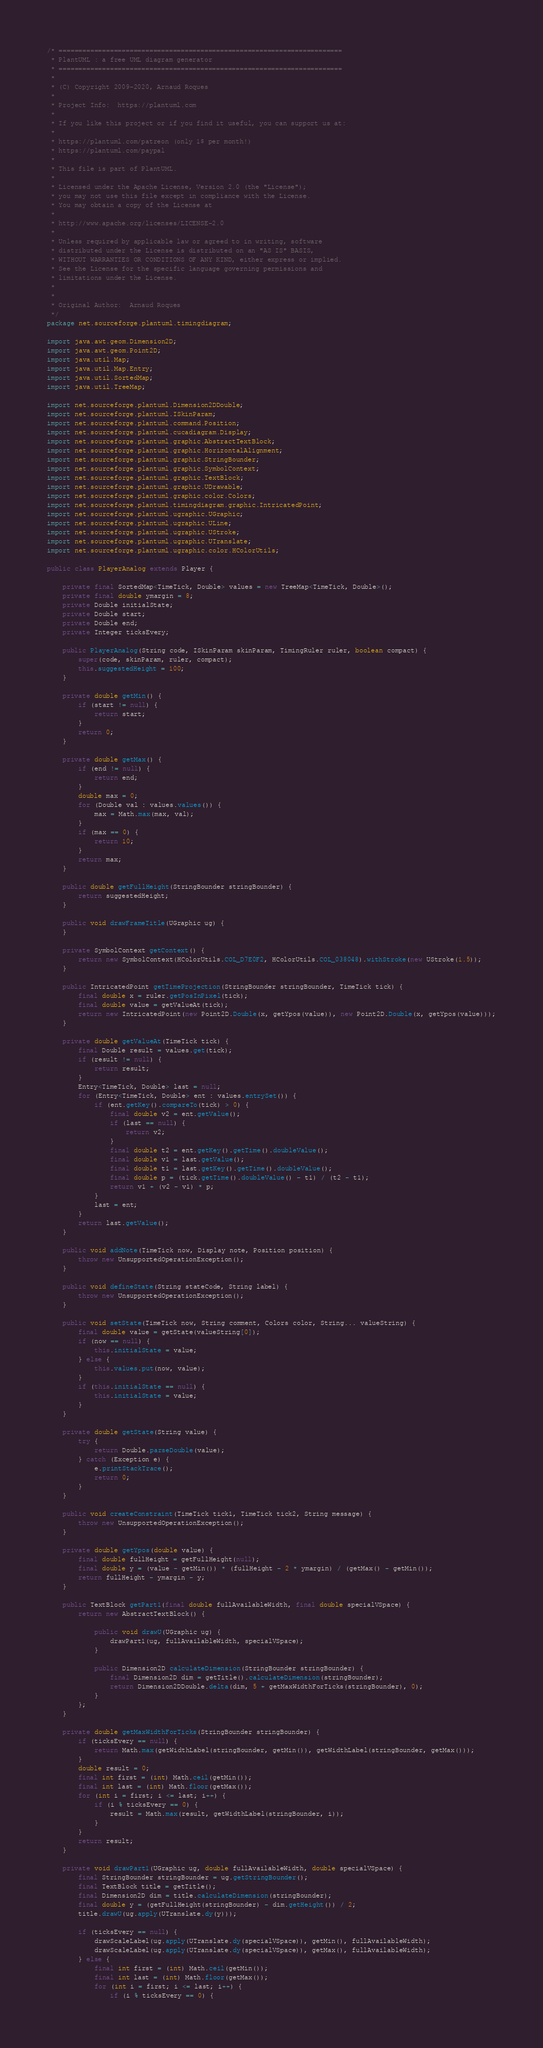Convert code to text. <code><loc_0><loc_0><loc_500><loc_500><_Java_>/* ========================================================================
 * PlantUML : a free UML diagram generator
 * ========================================================================
 *
 * (C) Copyright 2009-2020, Arnaud Roques
 *
 * Project Info:  https://plantuml.com
 * 
 * If you like this project or if you find it useful, you can support us at:
 * 
 * https://plantuml.com/patreon (only 1$ per month!)
 * https://plantuml.com/paypal
 * 
 * This file is part of PlantUML.
 *
 * Licensed under the Apache License, Version 2.0 (the "License");
 * you may not use this file except in compliance with the License.
 * You may obtain a copy of the License at
 * 
 * http://www.apache.org/licenses/LICENSE-2.0
 * 
 * Unless required by applicable law or agreed to in writing, software
 * distributed under the License is distributed on an "AS IS" BASIS,
 * WITHOUT WARRANTIES OR CONDITIONS OF ANY KIND, either express or implied.
 * See the License for the specific language governing permissions and
 * limitations under the License.
 *
 *
 * Original Author:  Arnaud Roques
 */
package net.sourceforge.plantuml.timingdiagram;

import java.awt.geom.Dimension2D;
import java.awt.geom.Point2D;
import java.util.Map;
import java.util.Map.Entry;
import java.util.SortedMap;
import java.util.TreeMap;

import net.sourceforge.plantuml.Dimension2DDouble;
import net.sourceforge.plantuml.ISkinParam;
import net.sourceforge.plantuml.command.Position;
import net.sourceforge.plantuml.cucadiagram.Display;
import net.sourceforge.plantuml.graphic.AbstractTextBlock;
import net.sourceforge.plantuml.graphic.HorizontalAlignment;
import net.sourceforge.plantuml.graphic.StringBounder;
import net.sourceforge.plantuml.graphic.SymbolContext;
import net.sourceforge.plantuml.graphic.TextBlock;
import net.sourceforge.plantuml.graphic.UDrawable;
import net.sourceforge.plantuml.graphic.color.Colors;
import net.sourceforge.plantuml.timingdiagram.graphic.IntricatedPoint;
import net.sourceforge.plantuml.ugraphic.UGraphic;
import net.sourceforge.plantuml.ugraphic.ULine;
import net.sourceforge.plantuml.ugraphic.UStroke;
import net.sourceforge.plantuml.ugraphic.UTranslate;
import net.sourceforge.plantuml.ugraphic.color.HColorUtils;

public class PlayerAnalog extends Player {

	private final SortedMap<TimeTick, Double> values = new TreeMap<TimeTick, Double>();
	private final double ymargin = 8;
	private Double initialState;
	private Double start;
	private Double end;
	private Integer ticksEvery;

	public PlayerAnalog(String code, ISkinParam skinParam, TimingRuler ruler, boolean compact) {
		super(code, skinParam, ruler, compact);
		this.suggestedHeight = 100;
	}

	private double getMin() {
		if (start != null) {
			return start;
		}
		return 0;
	}

	private double getMax() {
		if (end != null) {
			return end;
		}
		double max = 0;
		for (Double val : values.values()) {
			max = Math.max(max, val);
		}
		if (max == 0) {
			return 10;
		}
		return max;
	}

	public double getFullHeight(StringBounder stringBounder) {
		return suggestedHeight;
	}

	public void drawFrameTitle(UGraphic ug) {
	}

	private SymbolContext getContext() {
		return new SymbolContext(HColorUtils.COL_D7E0F2, HColorUtils.COL_038048).withStroke(new UStroke(1.5));
	}

	public IntricatedPoint getTimeProjection(StringBounder stringBounder, TimeTick tick) {
		final double x = ruler.getPosInPixel(tick);
		final double value = getValueAt(tick);
		return new IntricatedPoint(new Point2D.Double(x, getYpos(value)), new Point2D.Double(x, getYpos(value)));
	}

	private double getValueAt(TimeTick tick) {
		final Double result = values.get(tick);
		if (result != null) {
			return result;
		}
		Entry<TimeTick, Double> last = null;
		for (Entry<TimeTick, Double> ent : values.entrySet()) {
			if (ent.getKey().compareTo(tick) > 0) {
				final double v2 = ent.getValue();
				if (last == null) {
					return v2;
				}
				final double t2 = ent.getKey().getTime().doubleValue();
				final double v1 = last.getValue();
				final double t1 = last.getKey().getTime().doubleValue();
				final double p = (tick.getTime().doubleValue() - t1) / (t2 - t1);
				return v1 + (v2 - v1) * p;
			}
			last = ent;
		}
		return last.getValue();
	}

	public void addNote(TimeTick now, Display note, Position position) {
		throw new UnsupportedOperationException();
	}

	public void defineState(String stateCode, String label) {
		throw new UnsupportedOperationException();
	}

	public void setState(TimeTick now, String comment, Colors color, String... valueString) {
		final double value = getState(valueString[0]);
		if (now == null) {
			this.initialState = value;
		} else {
			this.values.put(now, value);
		}
		if (this.initialState == null) {
			this.initialState = value;
		}
	}

	private double getState(String value) {
		try {
			return Double.parseDouble(value);
		} catch (Exception e) {
			e.printStackTrace();
			return 0;
		}
	}

	public void createConstraint(TimeTick tick1, TimeTick tick2, String message) {
		throw new UnsupportedOperationException();
	}

	private double getYpos(double value) {
		final double fullHeight = getFullHeight(null);
		final double y = (value - getMin()) * (fullHeight - 2 * ymargin) / (getMax() - getMin());
		return fullHeight - ymargin - y;
	}

	public TextBlock getPart1(final double fullAvailableWidth, final double specialVSpace) {
		return new AbstractTextBlock() {

			public void drawU(UGraphic ug) {
				drawPart1(ug, fullAvailableWidth, specialVSpace);
			}

			public Dimension2D calculateDimension(StringBounder stringBounder) {
				final Dimension2D dim = getTitle().calculateDimension(stringBounder);
				return Dimension2DDouble.delta(dim, 5 + getMaxWidthForTicks(stringBounder), 0);
			}
		};
	}

	private double getMaxWidthForTicks(StringBounder stringBounder) {
		if (ticksEvery == null) {
			return Math.max(getWidthLabel(stringBounder, getMin()), getWidthLabel(stringBounder, getMax()));
		}
		double result = 0;
		final int first = (int) Math.ceil(getMin());
		final int last = (int) Math.floor(getMax());
		for (int i = first; i <= last; i++) {
			if (i % ticksEvery == 0) {
				result = Math.max(result, getWidthLabel(stringBounder, i));
			}
		}
		return result;
	}

	private void drawPart1(UGraphic ug, double fullAvailableWidth, double specialVSpace) {
		final StringBounder stringBounder = ug.getStringBounder();
		final TextBlock title = getTitle();
		final Dimension2D dim = title.calculateDimension(stringBounder);
		final double y = (getFullHeight(stringBounder) - dim.getHeight()) / 2;
		title.drawU(ug.apply(UTranslate.dy(y)));

		if (ticksEvery == null) {
			drawScaleLabel(ug.apply(UTranslate.dy(specialVSpace)), getMin(), fullAvailableWidth);
			drawScaleLabel(ug.apply(UTranslate.dy(specialVSpace)), getMax(), fullAvailableWidth);
		} else {
			final int first = (int) Math.ceil(getMin());
			final int last = (int) Math.floor(getMax());
			for (int i = first; i <= last; i++) {
				if (i % ticksEvery == 0) {</code> 